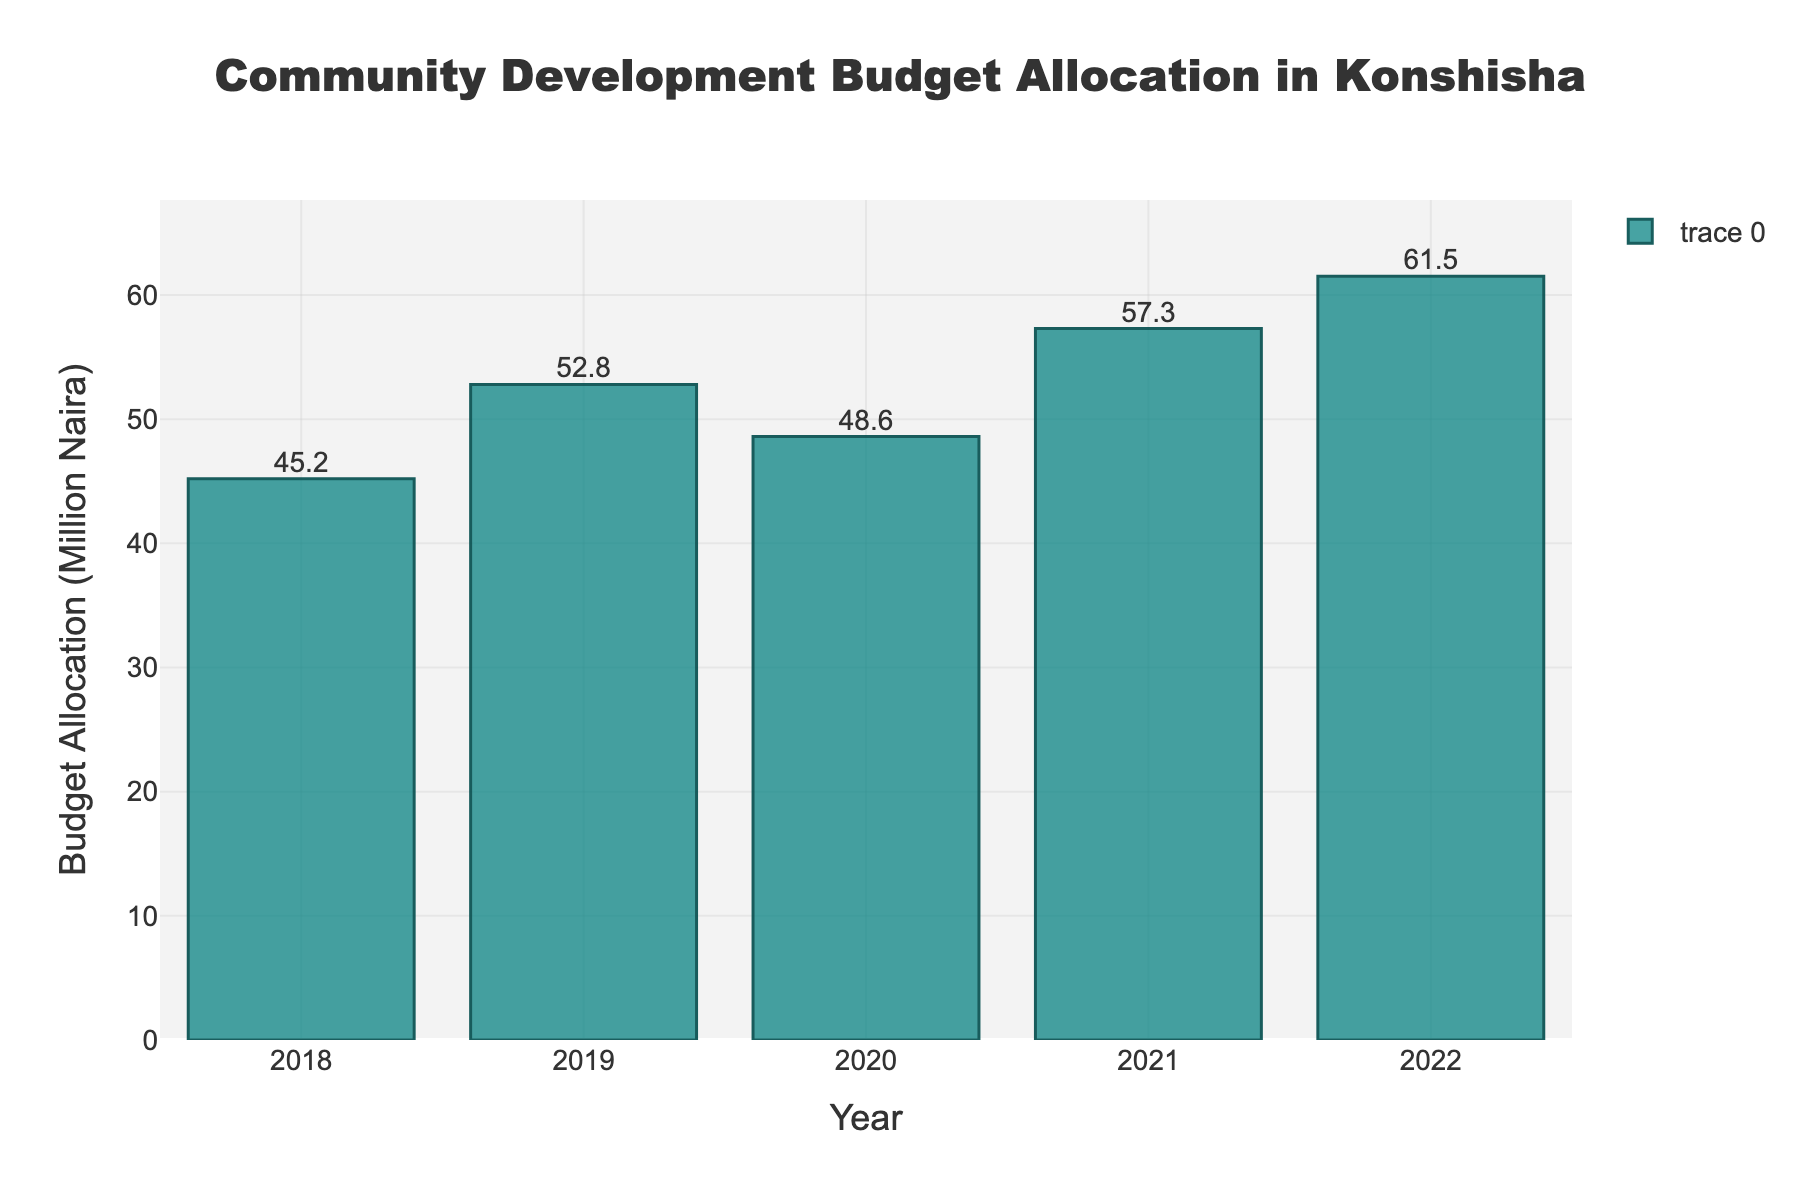What is the total budget allocated for community development projects from 2018 to 2022? To find the total budget allocated from 2018 to 2022, add up the budget values for each year: 45.2 (2018) + 52.8 (2019) + 48.6 (2020) + 57.3 (2021) + 61.5 (2022) = 265.4 million Naira
Answer: 265.4 million Naira Which year had the highest budget allocation? Compare the budget allocations for all five years: 2018 (45.2), 2019 (52.8), 2020 (48.6), 2021 (57.3), 2022 (61.5). The highest value is 61.5 in 2022
Answer: 2022 How much was the budget allocation in 2020 compared to 2019? To find the difference between 2019 and 2020, subtract the 2020 value from the 2019 value: 52.8 (2019) - 48.6 (2020) = 4.2 million Naira less in 2020
Answer: 4.2 million Naira less By what percentage did the budget allocation increase from 2021 to 2022? To calculate the percentage increase, first find the difference between the two years: 61.5 (2022) - 57.3 (2021) = 4.2. Then, divide the difference by the 2021 value and multiply by 100: (4.2 / 57.3) * 100 = 7.33%
Answer: 7.33% What is the average budget allocation over these five years? To find the average, add up the budget values and divide by the number of years: (45.2 + 52.8 + 48.6 + 57.3 + 61.5) / 5 = 53.08 million Naira
Answer: 53.08 million Naira Which year had the smallest budget increase compared to the previous year? Calculate the year-on-year increases: 2019 - 2018: 52.8 - 45.2 = 7.6, 2020 - 2019: 48.6 - 52.8 = -4.2, 2021 - 2020: 57.3 - 48.6 = 8.7, 2022 - 2021: 61.5 - 57.3 = 4.2. The smallest increase (or largest decrease) is -4.2 from 2019 to 2020
Answer: 2020 If a similar trend continues, what might the budget allocation be in 2023? To estimate, note the average yearly increase over the last four years: (7.6 + (-4.2) + 8.7 + 4.2) / 4 = 4.075. Adding this average increase to the 2022 value: 61.5 + 4.075 ≈ 65.575 million Naira
Answer: 65.575 million Naira 